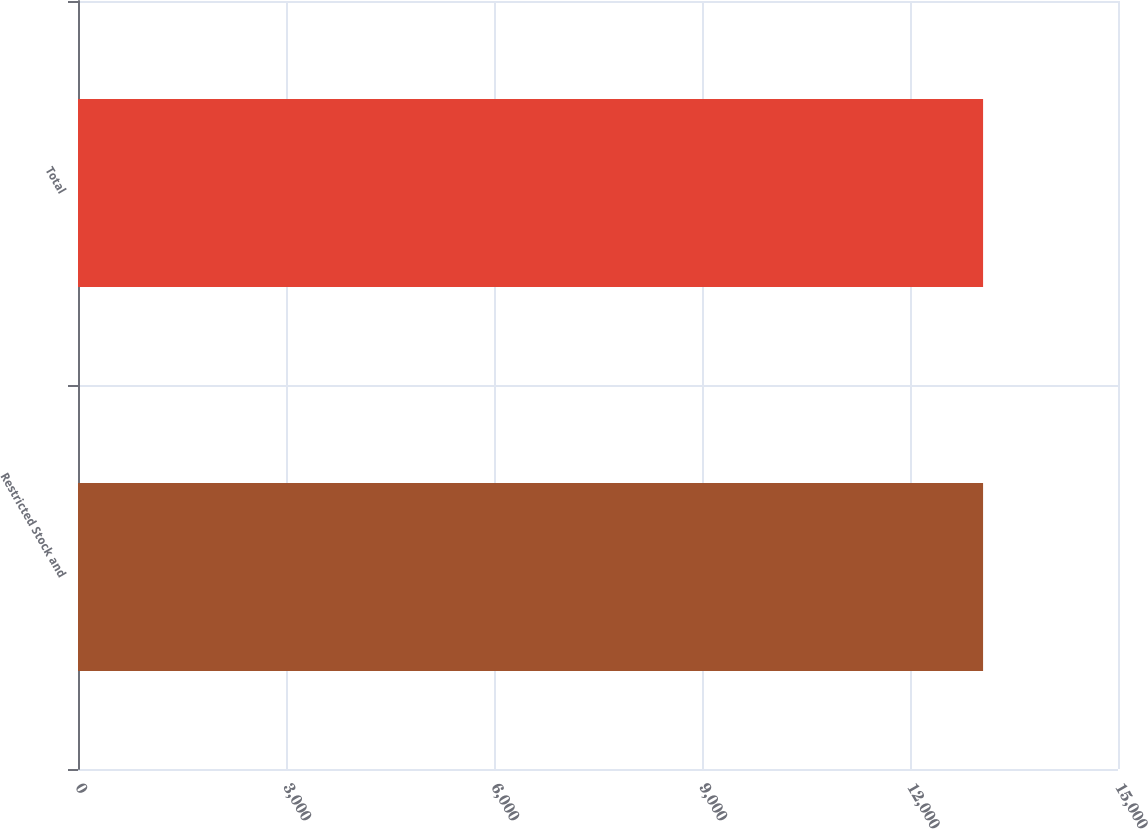Convert chart. <chart><loc_0><loc_0><loc_500><loc_500><bar_chart><fcel>Restricted Stock and<fcel>Total<nl><fcel>13054<fcel>13054.1<nl></chart> 